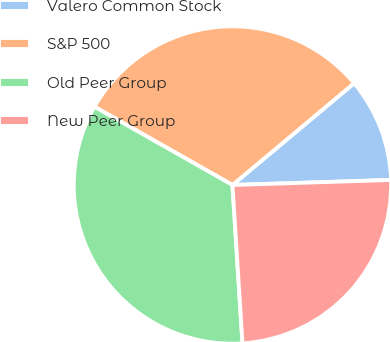Convert chart. <chart><loc_0><loc_0><loc_500><loc_500><pie_chart><fcel>Valero Common Stock<fcel>S&P 500<fcel>Old Peer Group<fcel>New Peer Group<nl><fcel>10.58%<fcel>30.7%<fcel>34.22%<fcel>24.5%<nl></chart> 